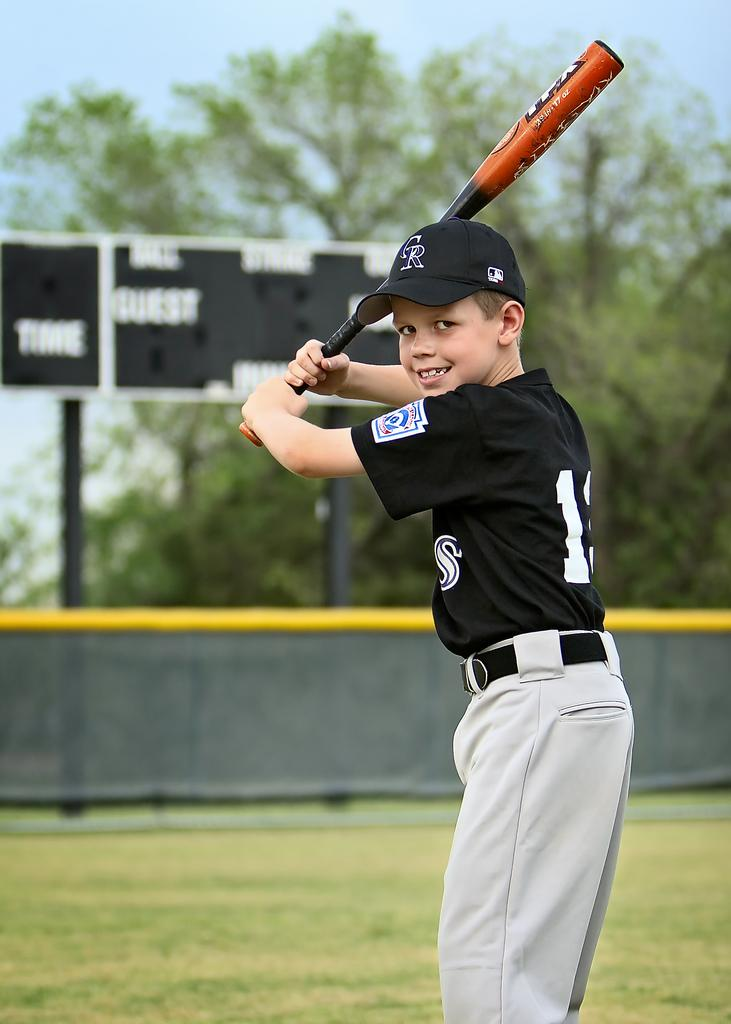<image>
Provide a brief description of the given image. A boy with the letters CR on his hat holds up a baseball bat. 